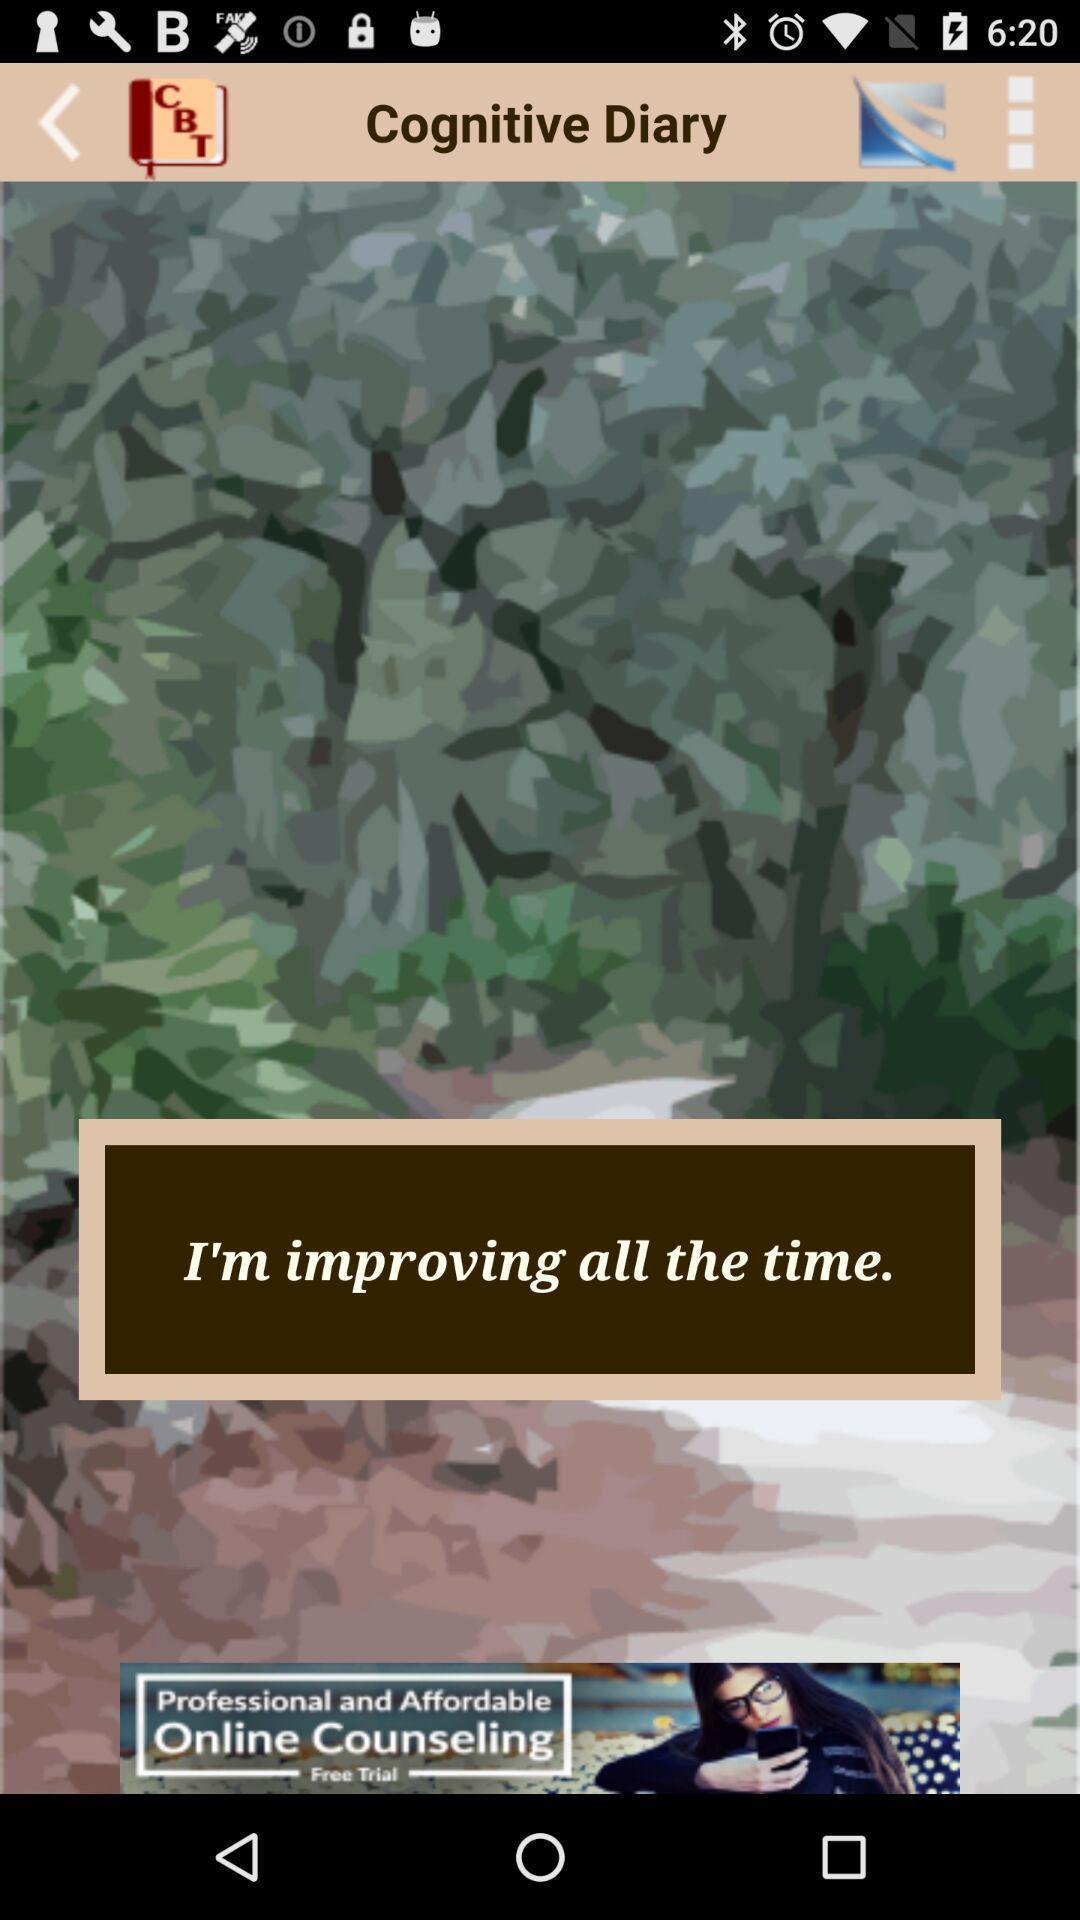Describe this image in words. Screen page displaying an image with text. 